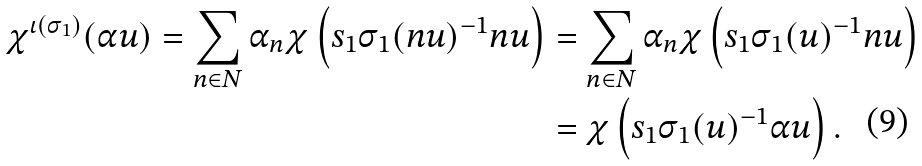Convert formula to latex. <formula><loc_0><loc_0><loc_500><loc_500>\chi ^ { \iota ( \sigma _ { 1 } ) } ( \alpha u ) = \sum _ { n \in N } \alpha _ { n } \chi \left ( s _ { 1 } \sigma _ { 1 } ( n u ) ^ { - 1 } n u \right ) & = \sum _ { n \in N } \alpha _ { n } \chi \left ( s _ { 1 } \sigma _ { 1 } ( u ) ^ { - 1 } n u \right ) \\ & = \chi \left ( s _ { 1 } \sigma _ { 1 } ( u ) ^ { - 1 } \alpha u \right ) .</formula> 